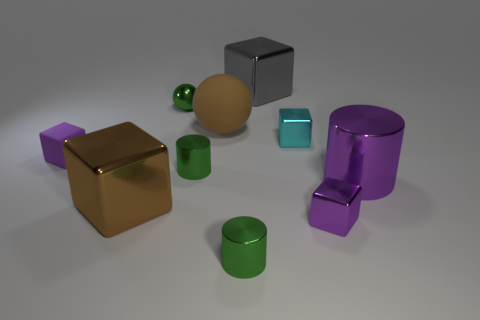Subtract 2 blocks. How many blocks are left? 3 Subtract all cyan blocks. How many blocks are left? 4 Subtract all purple metallic cubes. How many cubes are left? 4 Subtract all green blocks. Subtract all yellow cylinders. How many blocks are left? 5 Subtract all cylinders. How many objects are left? 7 Add 3 gray blocks. How many gray blocks are left? 4 Add 6 cyan rubber balls. How many cyan rubber balls exist? 6 Subtract 1 brown cubes. How many objects are left? 9 Subtract all small green cylinders. Subtract all brown metallic things. How many objects are left? 7 